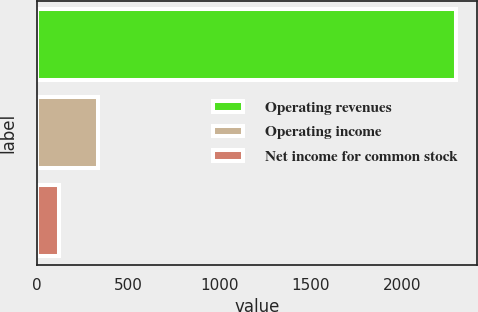Convert chart. <chart><loc_0><loc_0><loc_500><loc_500><bar_chart><fcel>Operating revenues<fcel>Operating income<fcel>Net income for common stock<nl><fcel>2294<fcel>338.3<fcel>121<nl></chart> 